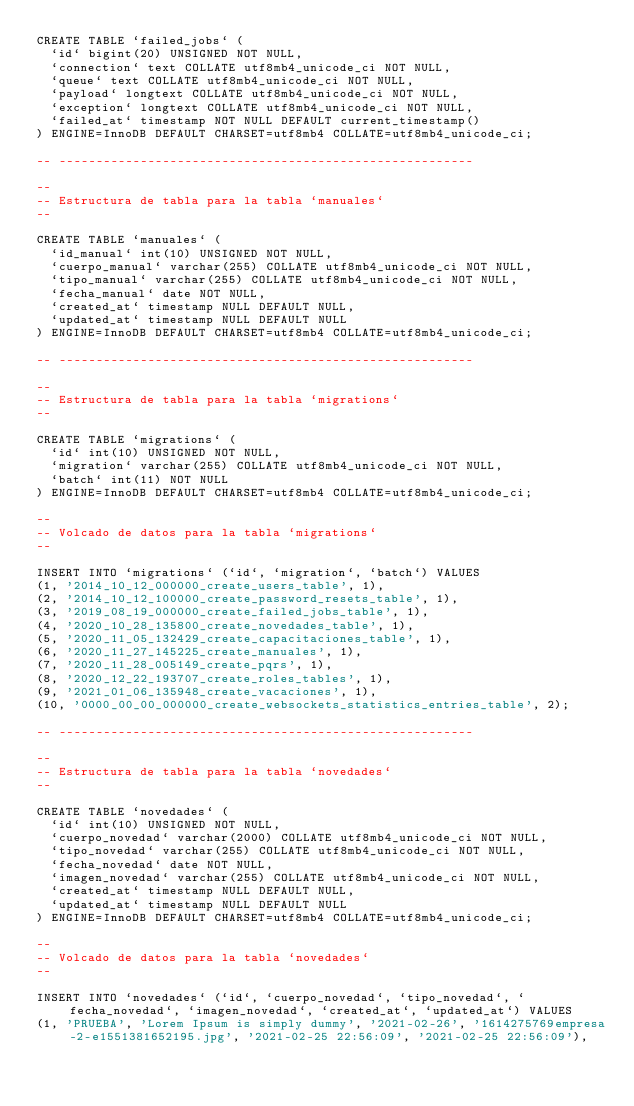<code> <loc_0><loc_0><loc_500><loc_500><_SQL_>CREATE TABLE `failed_jobs` (
  `id` bigint(20) UNSIGNED NOT NULL,
  `connection` text COLLATE utf8mb4_unicode_ci NOT NULL,
  `queue` text COLLATE utf8mb4_unicode_ci NOT NULL,
  `payload` longtext COLLATE utf8mb4_unicode_ci NOT NULL,
  `exception` longtext COLLATE utf8mb4_unicode_ci NOT NULL,
  `failed_at` timestamp NOT NULL DEFAULT current_timestamp()
) ENGINE=InnoDB DEFAULT CHARSET=utf8mb4 COLLATE=utf8mb4_unicode_ci;

-- --------------------------------------------------------

--
-- Estructura de tabla para la tabla `manuales`
--

CREATE TABLE `manuales` (
  `id_manual` int(10) UNSIGNED NOT NULL,
  `cuerpo_manual` varchar(255) COLLATE utf8mb4_unicode_ci NOT NULL,
  `tipo_manual` varchar(255) COLLATE utf8mb4_unicode_ci NOT NULL,
  `fecha_manual` date NOT NULL,
  `created_at` timestamp NULL DEFAULT NULL,
  `updated_at` timestamp NULL DEFAULT NULL
) ENGINE=InnoDB DEFAULT CHARSET=utf8mb4 COLLATE=utf8mb4_unicode_ci;

-- --------------------------------------------------------

--
-- Estructura de tabla para la tabla `migrations`
--

CREATE TABLE `migrations` (
  `id` int(10) UNSIGNED NOT NULL,
  `migration` varchar(255) COLLATE utf8mb4_unicode_ci NOT NULL,
  `batch` int(11) NOT NULL
) ENGINE=InnoDB DEFAULT CHARSET=utf8mb4 COLLATE=utf8mb4_unicode_ci;

--
-- Volcado de datos para la tabla `migrations`
--

INSERT INTO `migrations` (`id`, `migration`, `batch`) VALUES
(1, '2014_10_12_000000_create_users_table', 1),
(2, '2014_10_12_100000_create_password_resets_table', 1),
(3, '2019_08_19_000000_create_failed_jobs_table', 1),
(4, '2020_10_28_135800_create_novedades_table', 1),
(5, '2020_11_05_132429_create_capacitaciones_table', 1),
(6, '2020_11_27_145225_create_manuales', 1),
(7, '2020_11_28_005149_create_pqrs', 1),
(8, '2020_12_22_193707_create_roles_tables', 1),
(9, '2021_01_06_135948_create_vacaciones', 1),
(10, '0000_00_00_000000_create_websockets_statistics_entries_table', 2);

-- --------------------------------------------------------

--
-- Estructura de tabla para la tabla `novedades`
--

CREATE TABLE `novedades` (
  `id` int(10) UNSIGNED NOT NULL,
  `cuerpo_novedad` varchar(2000) COLLATE utf8mb4_unicode_ci NOT NULL,
  `tipo_novedad` varchar(255) COLLATE utf8mb4_unicode_ci NOT NULL,
  `fecha_novedad` date NOT NULL,
  `imagen_novedad` varchar(255) COLLATE utf8mb4_unicode_ci NOT NULL,
  `created_at` timestamp NULL DEFAULT NULL,
  `updated_at` timestamp NULL DEFAULT NULL
) ENGINE=InnoDB DEFAULT CHARSET=utf8mb4 COLLATE=utf8mb4_unicode_ci;

--
-- Volcado de datos para la tabla `novedades`
--

INSERT INTO `novedades` (`id`, `cuerpo_novedad`, `tipo_novedad`, `fecha_novedad`, `imagen_novedad`, `created_at`, `updated_at`) VALUES
(1, 'PRUEBA', 'Lorem Ipsum is simply dummy', '2021-02-26', '1614275769empresa-2-e1551381652195.jpg', '2021-02-25 22:56:09', '2021-02-25 22:56:09'),</code> 